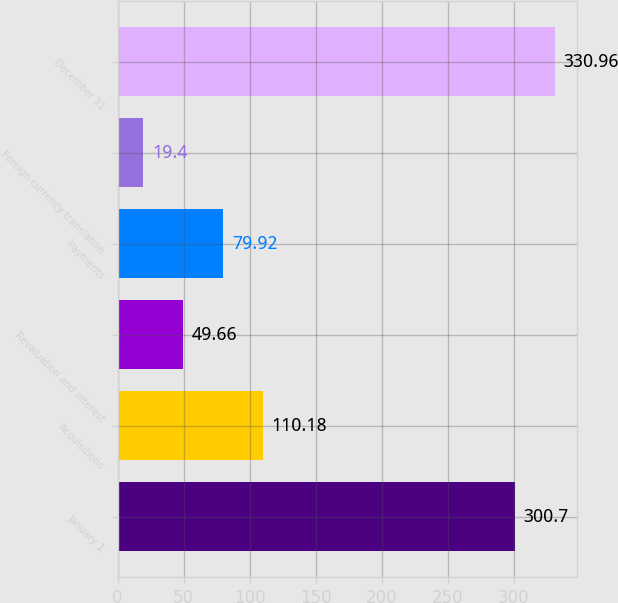<chart> <loc_0><loc_0><loc_500><loc_500><bar_chart><fcel>January 1<fcel>Acquisitions<fcel>Revaluation and interest<fcel>Payments<fcel>Foreign currency translation<fcel>December 31<nl><fcel>300.7<fcel>110.18<fcel>49.66<fcel>79.92<fcel>19.4<fcel>330.96<nl></chart> 